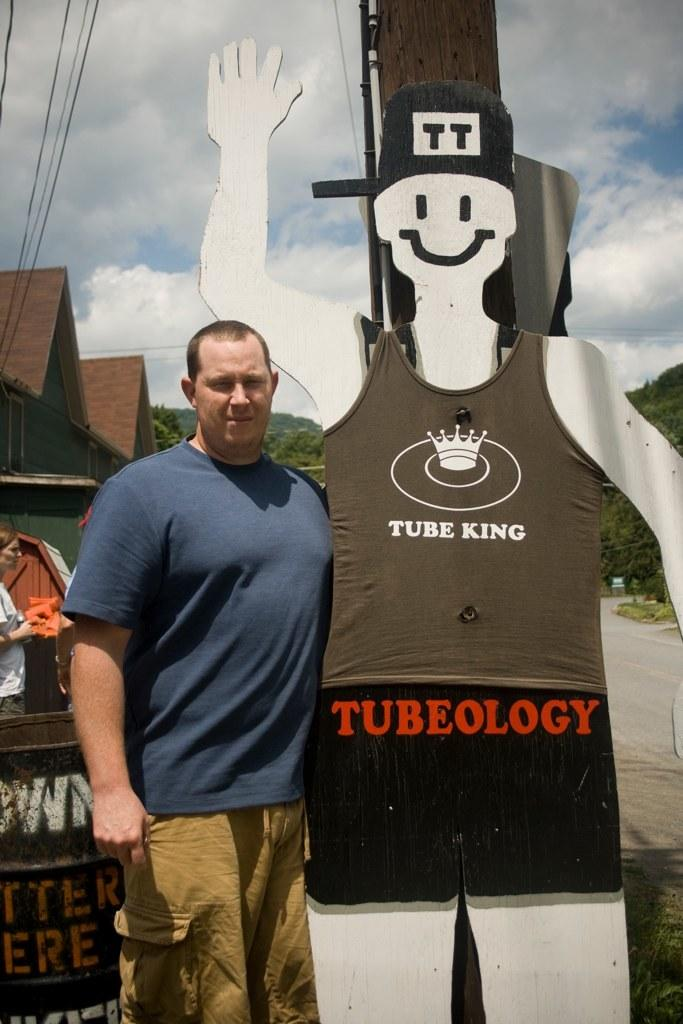Who or what can be seen in the image? There are people in the image. What is located in the middle of the image? There is a hoarding in the middle of the image. What can be seen in the background of the image? There are houses, cables, trees, and clouds visible in the background of the image. What type of apples are being sold on the hoarding in the image? There are no apples present on the hoarding in the image; it does not depict any fruits or food items. 